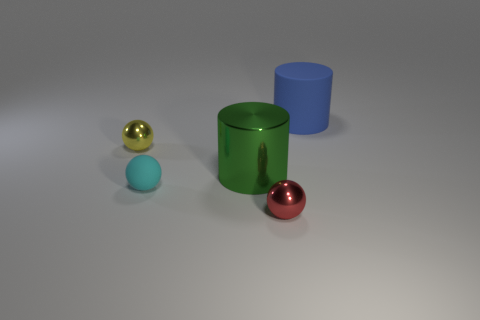Add 4 large rubber objects. How many objects exist? 9 Subtract all spheres. How many objects are left? 2 Subtract 0 red cylinders. How many objects are left? 5 Subtract all small gray spheres. Subtract all tiny matte spheres. How many objects are left? 4 Add 4 tiny red things. How many tiny red things are left? 5 Add 1 cyan balls. How many cyan balls exist? 2 